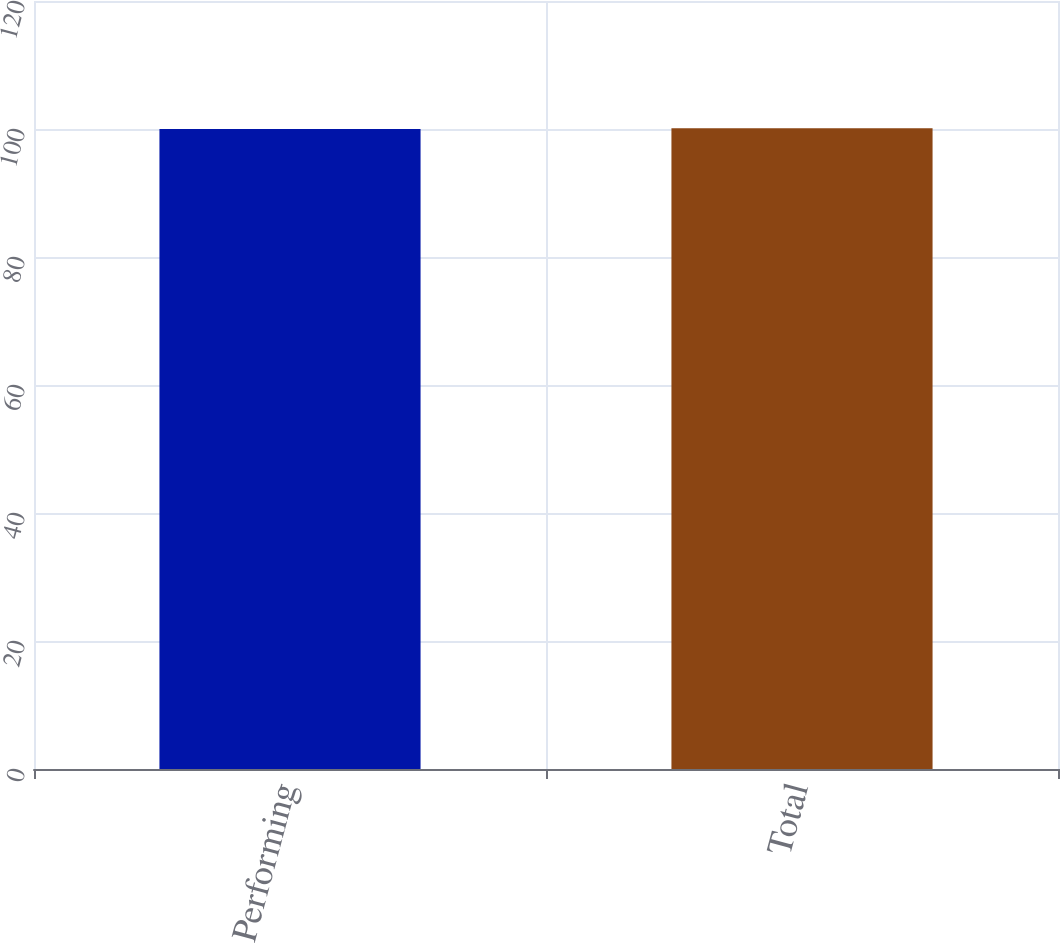Convert chart to OTSL. <chart><loc_0><loc_0><loc_500><loc_500><bar_chart><fcel>Performing<fcel>Total<nl><fcel>100<fcel>100.1<nl></chart> 